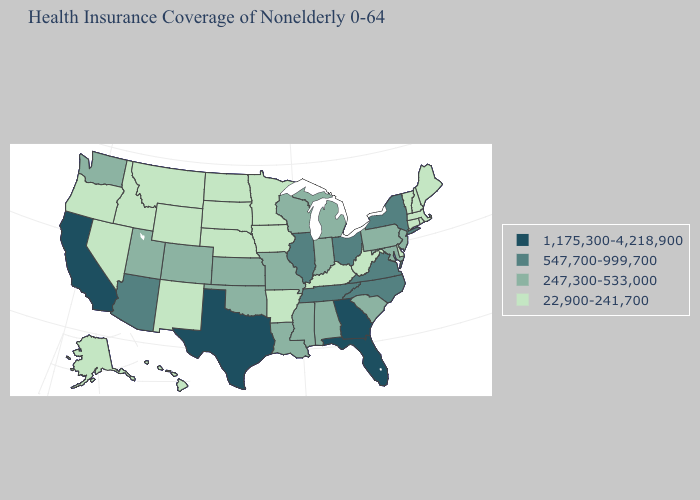Name the states that have a value in the range 22,900-241,700?
Write a very short answer. Alaska, Arkansas, Connecticut, Delaware, Hawaii, Idaho, Iowa, Kentucky, Maine, Massachusetts, Minnesota, Montana, Nebraska, Nevada, New Hampshire, New Mexico, North Dakota, Oregon, Rhode Island, South Dakota, Vermont, West Virginia, Wyoming. What is the lowest value in the Northeast?
Answer briefly. 22,900-241,700. What is the value of Hawaii?
Keep it brief. 22,900-241,700. Among the states that border Tennessee , does Alabama have the lowest value?
Keep it brief. No. Does Texas have the highest value in the USA?
Quick response, please. Yes. Name the states that have a value in the range 247,300-533,000?
Write a very short answer. Alabama, Colorado, Indiana, Kansas, Louisiana, Maryland, Michigan, Mississippi, Missouri, New Jersey, Oklahoma, Pennsylvania, South Carolina, Utah, Washington, Wisconsin. Name the states that have a value in the range 547,700-999,700?
Give a very brief answer. Arizona, Illinois, New York, North Carolina, Ohio, Tennessee, Virginia. Among the states that border Oregon , does Washington have the highest value?
Write a very short answer. No. What is the value of California?
Give a very brief answer. 1,175,300-4,218,900. Is the legend a continuous bar?
Answer briefly. No. Does Indiana have the highest value in the MidWest?
Answer briefly. No. What is the highest value in states that border Massachusetts?
Answer briefly. 547,700-999,700. Name the states that have a value in the range 1,175,300-4,218,900?
Write a very short answer. California, Florida, Georgia, Texas. Does Minnesota have the same value as Arkansas?
Be succinct. Yes. Name the states that have a value in the range 22,900-241,700?
Answer briefly. Alaska, Arkansas, Connecticut, Delaware, Hawaii, Idaho, Iowa, Kentucky, Maine, Massachusetts, Minnesota, Montana, Nebraska, Nevada, New Hampshire, New Mexico, North Dakota, Oregon, Rhode Island, South Dakota, Vermont, West Virginia, Wyoming. 